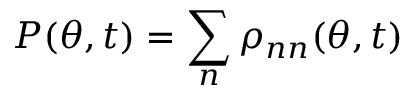<formula> <loc_0><loc_0><loc_500><loc_500>P ( \theta , t ) = \sum _ { n } \rho _ { n n } ( \theta , t )</formula> 